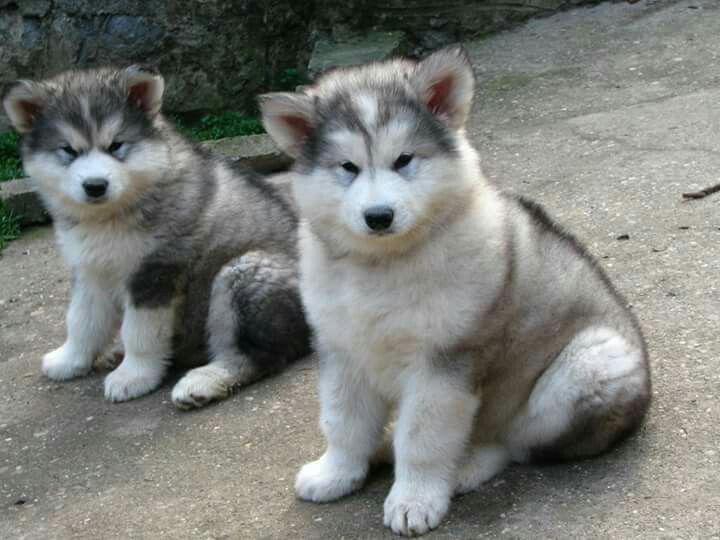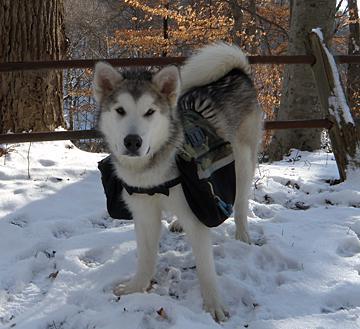The first image is the image on the left, the second image is the image on the right. For the images shown, is this caption "The left image contains exactly two husky dogs of similar size and age posed with bodies turned leftward, mouths closed, and gazes matched." true? Answer yes or no. Yes. The first image is the image on the left, the second image is the image on the right. For the images displayed, is the sentence "The right image contains exactly one dog." factually correct? Answer yes or no. Yes. 